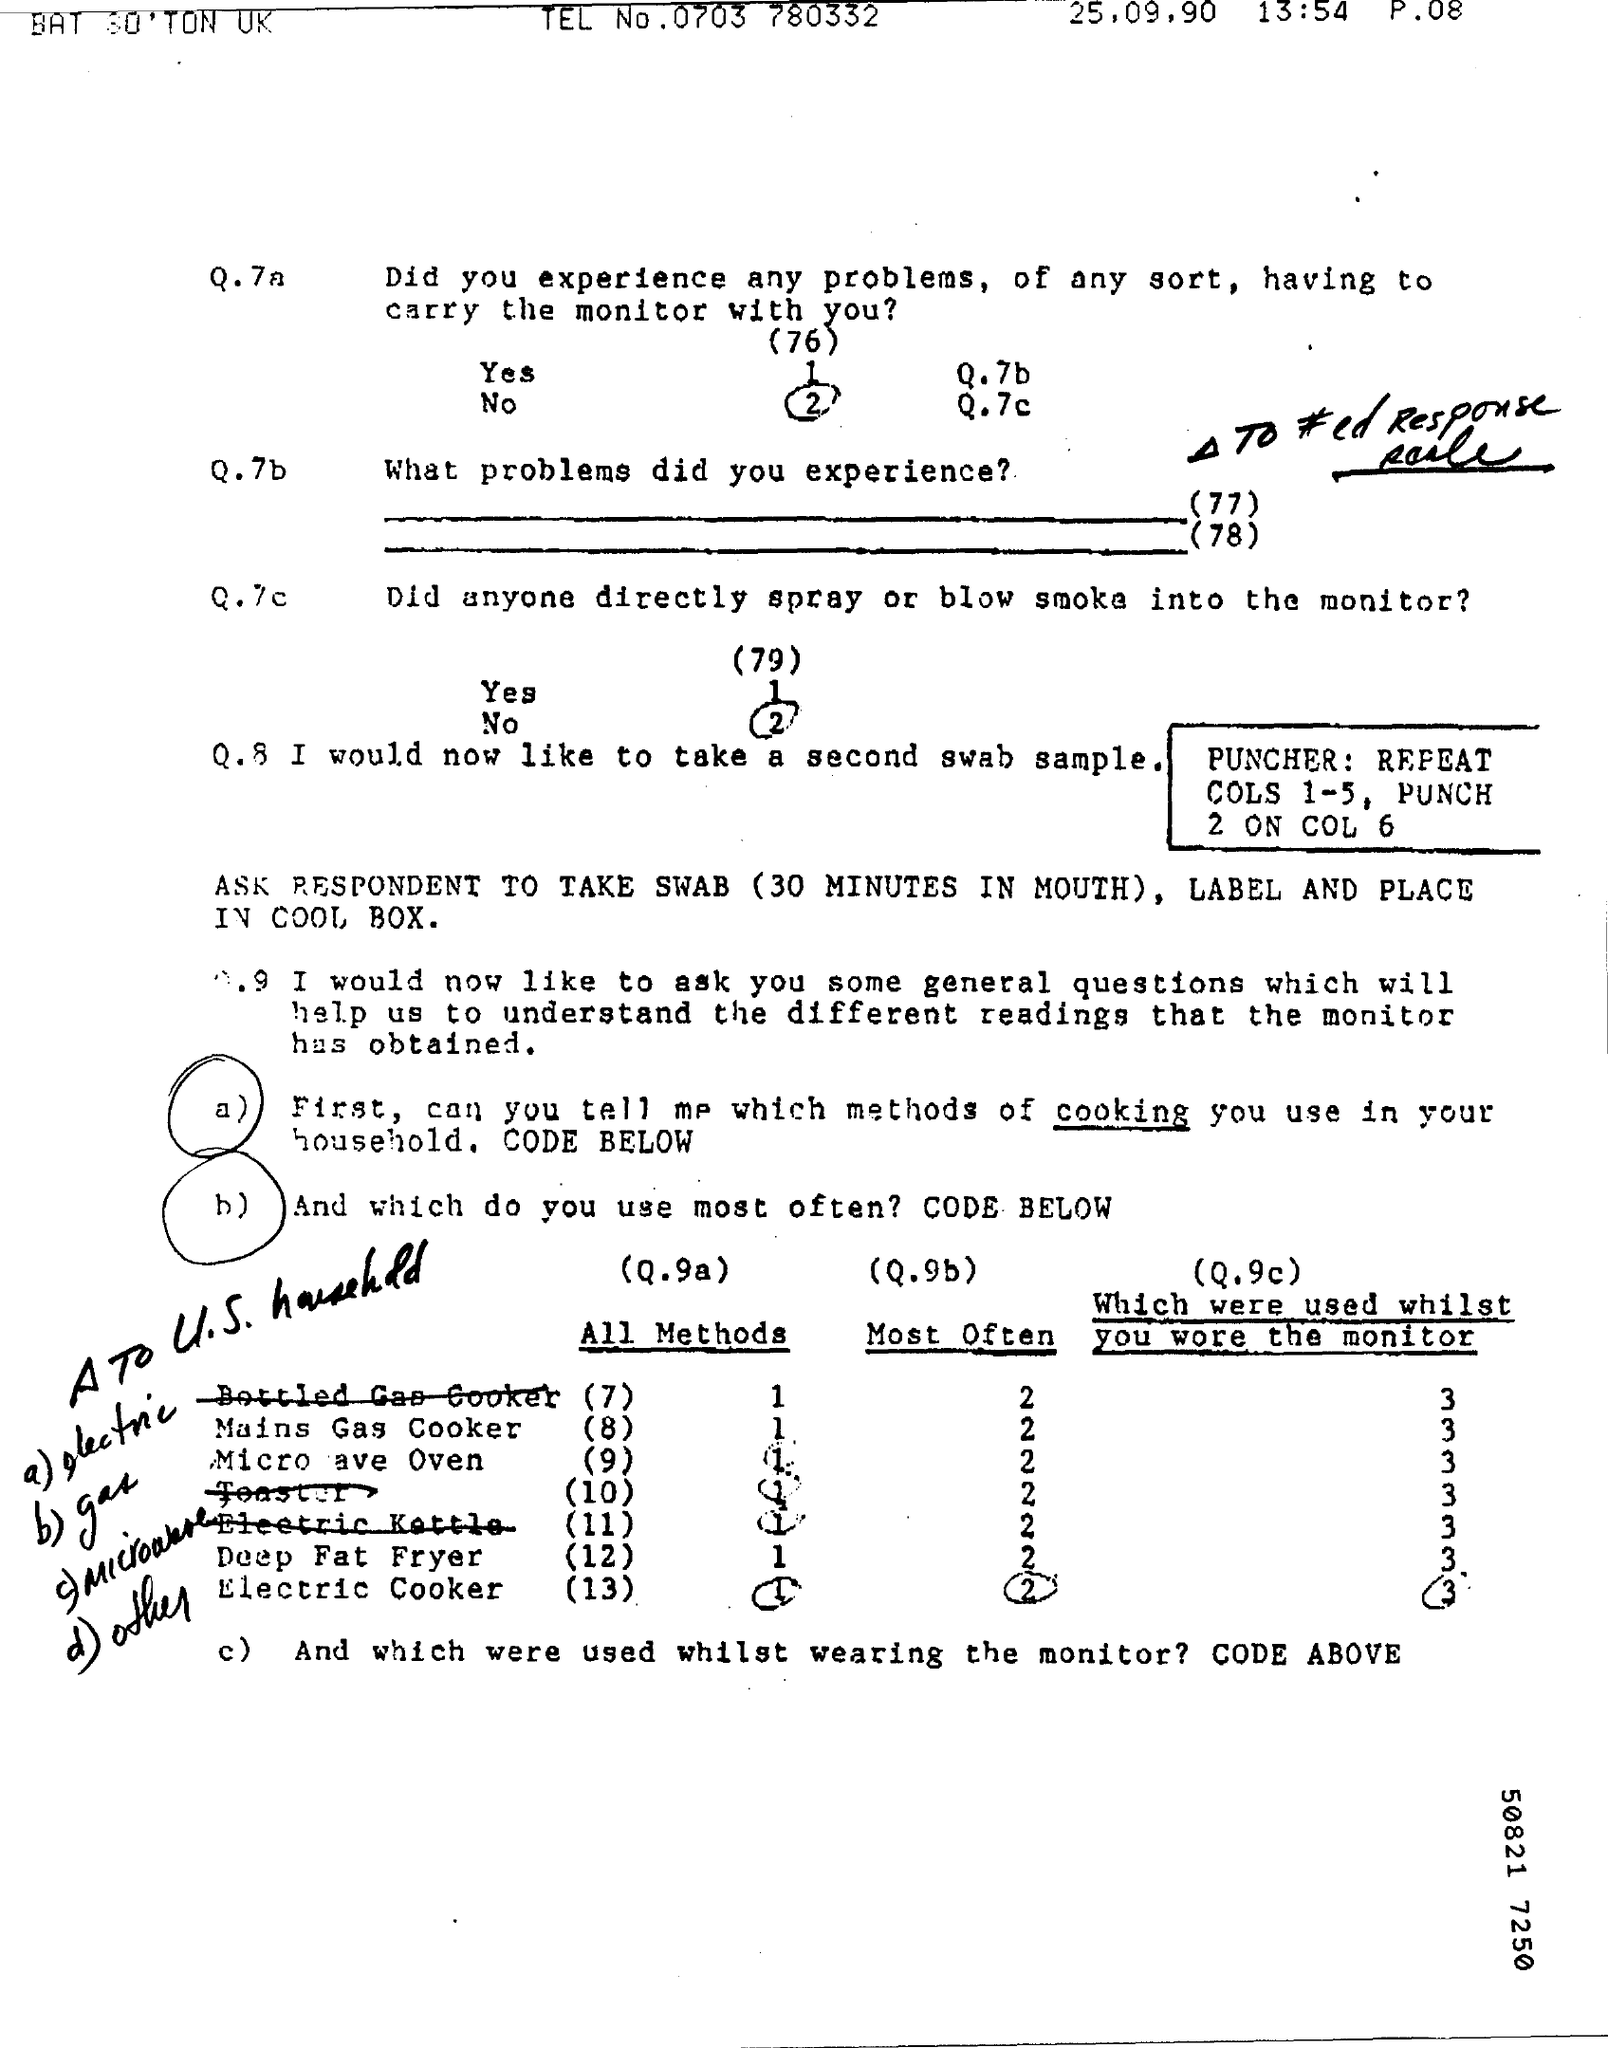What is the Tel No.?
Ensure brevity in your answer.  0703 780332. What is the date on the document?
Keep it short and to the point. 25.09.90. 